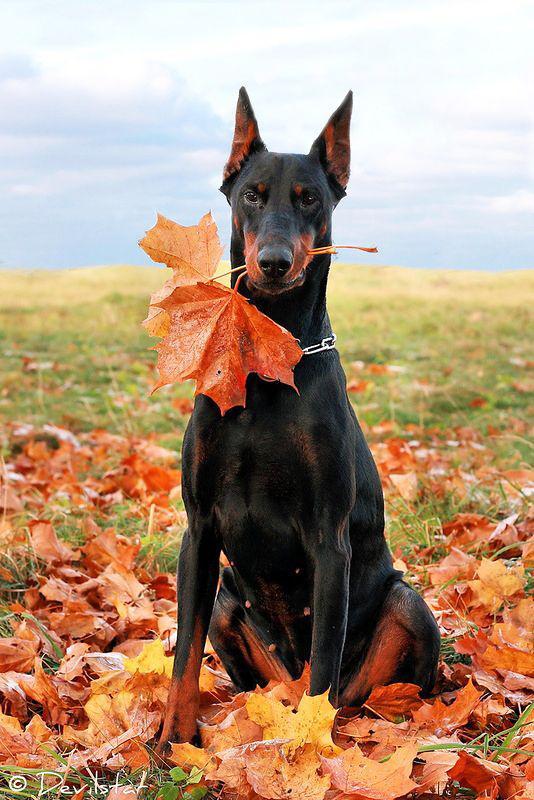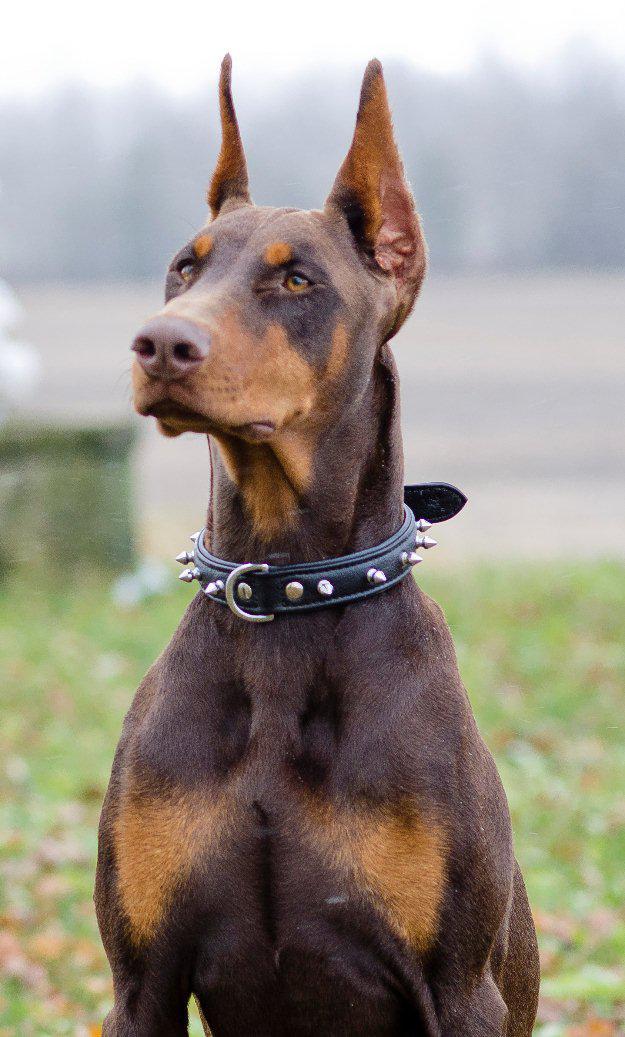The first image is the image on the left, the second image is the image on the right. Analyze the images presented: Is the assertion "The left image shows a doberman with erect ears and docked tail standing with his chest facing forward in front of at least one tall tree." valid? Answer yes or no. No. The first image is the image on the left, the second image is the image on the right. Analyze the images presented: Is the assertion "in at least one image there is a thin black and brown dog facing forward with their head tilted slightly left." valid? Answer yes or no. Yes. 